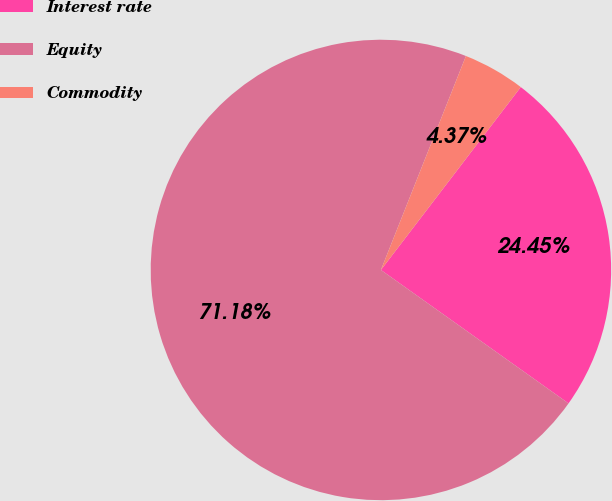Convert chart. <chart><loc_0><loc_0><loc_500><loc_500><pie_chart><fcel>Interest rate<fcel>Equity<fcel>Commodity<nl><fcel>24.45%<fcel>71.18%<fcel>4.37%<nl></chart> 